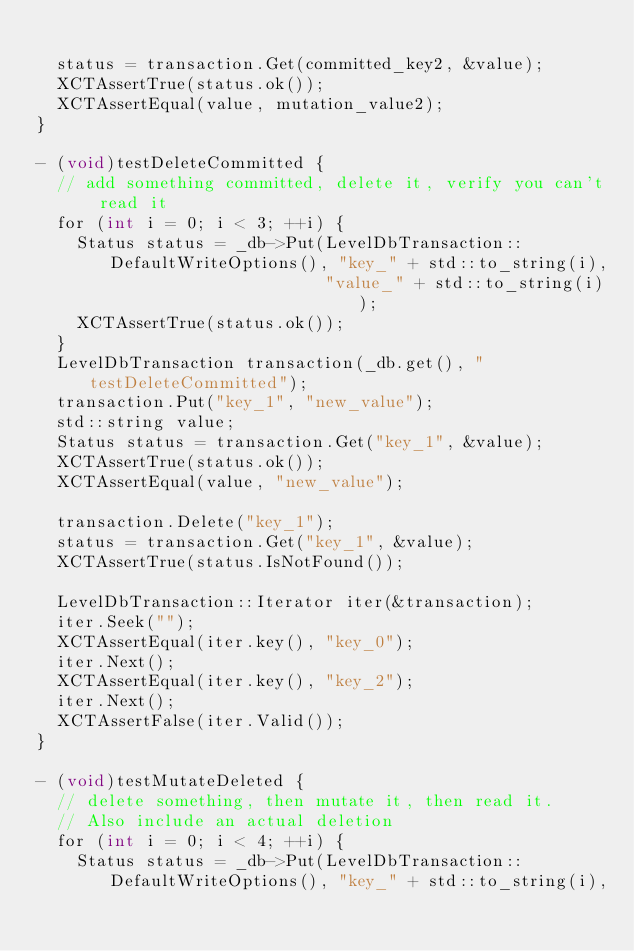Convert code to text. <code><loc_0><loc_0><loc_500><loc_500><_ObjectiveC_>
  status = transaction.Get(committed_key2, &value);
  XCTAssertTrue(status.ok());
  XCTAssertEqual(value, mutation_value2);
}

- (void)testDeleteCommitted {
  // add something committed, delete it, verify you can't read it
  for (int i = 0; i < 3; ++i) {
    Status status = _db->Put(LevelDbTransaction::DefaultWriteOptions(), "key_" + std::to_string(i),
                             "value_" + std::to_string(i));
    XCTAssertTrue(status.ok());
  }
  LevelDbTransaction transaction(_db.get(), "testDeleteCommitted");
  transaction.Put("key_1", "new_value");
  std::string value;
  Status status = transaction.Get("key_1", &value);
  XCTAssertTrue(status.ok());
  XCTAssertEqual(value, "new_value");

  transaction.Delete("key_1");
  status = transaction.Get("key_1", &value);
  XCTAssertTrue(status.IsNotFound());

  LevelDbTransaction::Iterator iter(&transaction);
  iter.Seek("");
  XCTAssertEqual(iter.key(), "key_0");
  iter.Next();
  XCTAssertEqual(iter.key(), "key_2");
  iter.Next();
  XCTAssertFalse(iter.Valid());
}

- (void)testMutateDeleted {
  // delete something, then mutate it, then read it.
  // Also include an actual deletion
  for (int i = 0; i < 4; ++i) {
    Status status = _db->Put(LevelDbTransaction::DefaultWriteOptions(), "key_" + std::to_string(i),</code> 